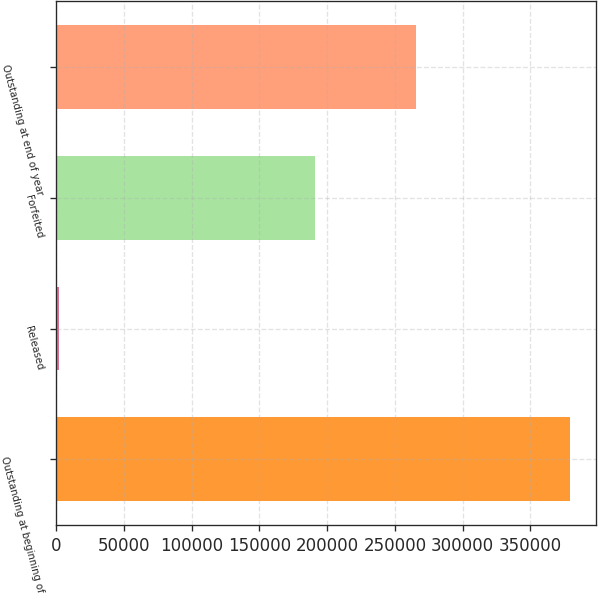Convert chart to OTSL. <chart><loc_0><loc_0><loc_500><loc_500><bar_chart><fcel>Outstanding at beginning of<fcel>Released<fcel>Forfeited<fcel>Outstanding at end of year<nl><fcel>379226<fcel>2029<fcel>190873<fcel>265747<nl></chart> 